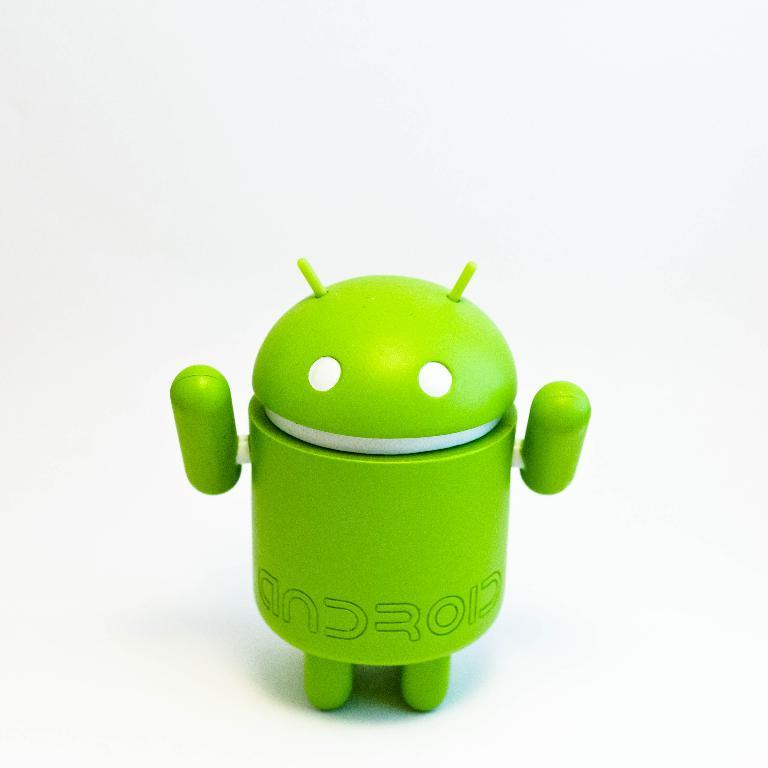Provide a one-sentence caption for the provided image. a green android figure on a white surface. 